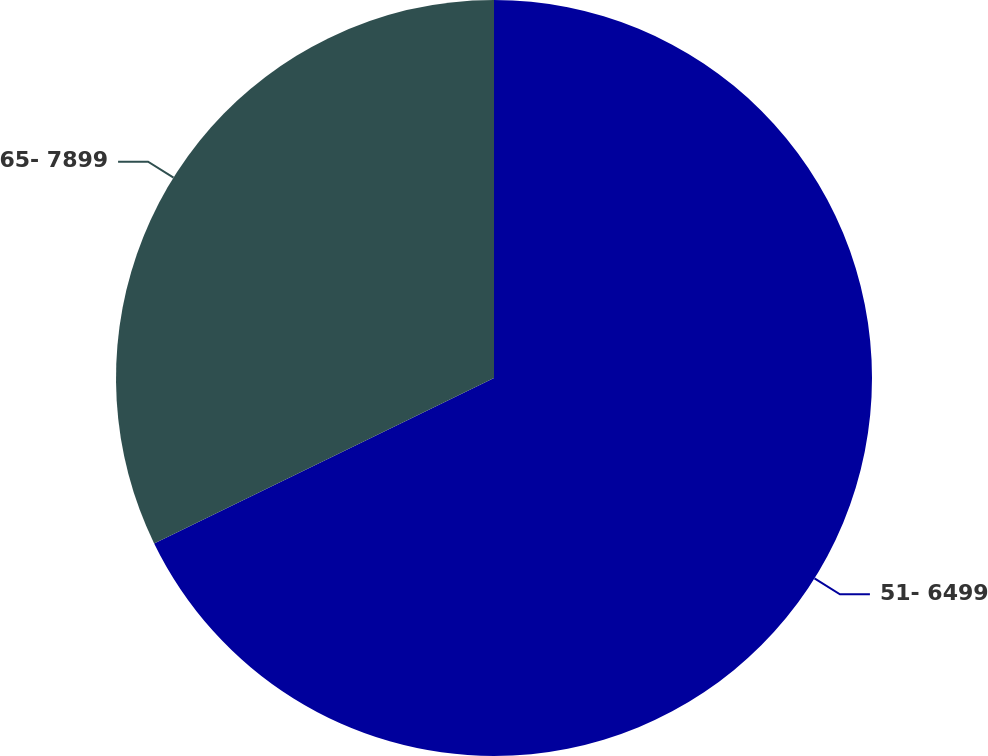Convert chart to OTSL. <chart><loc_0><loc_0><loc_500><loc_500><pie_chart><fcel>51- 6499<fcel>65- 7899<nl><fcel>67.79%<fcel>32.21%<nl></chart> 